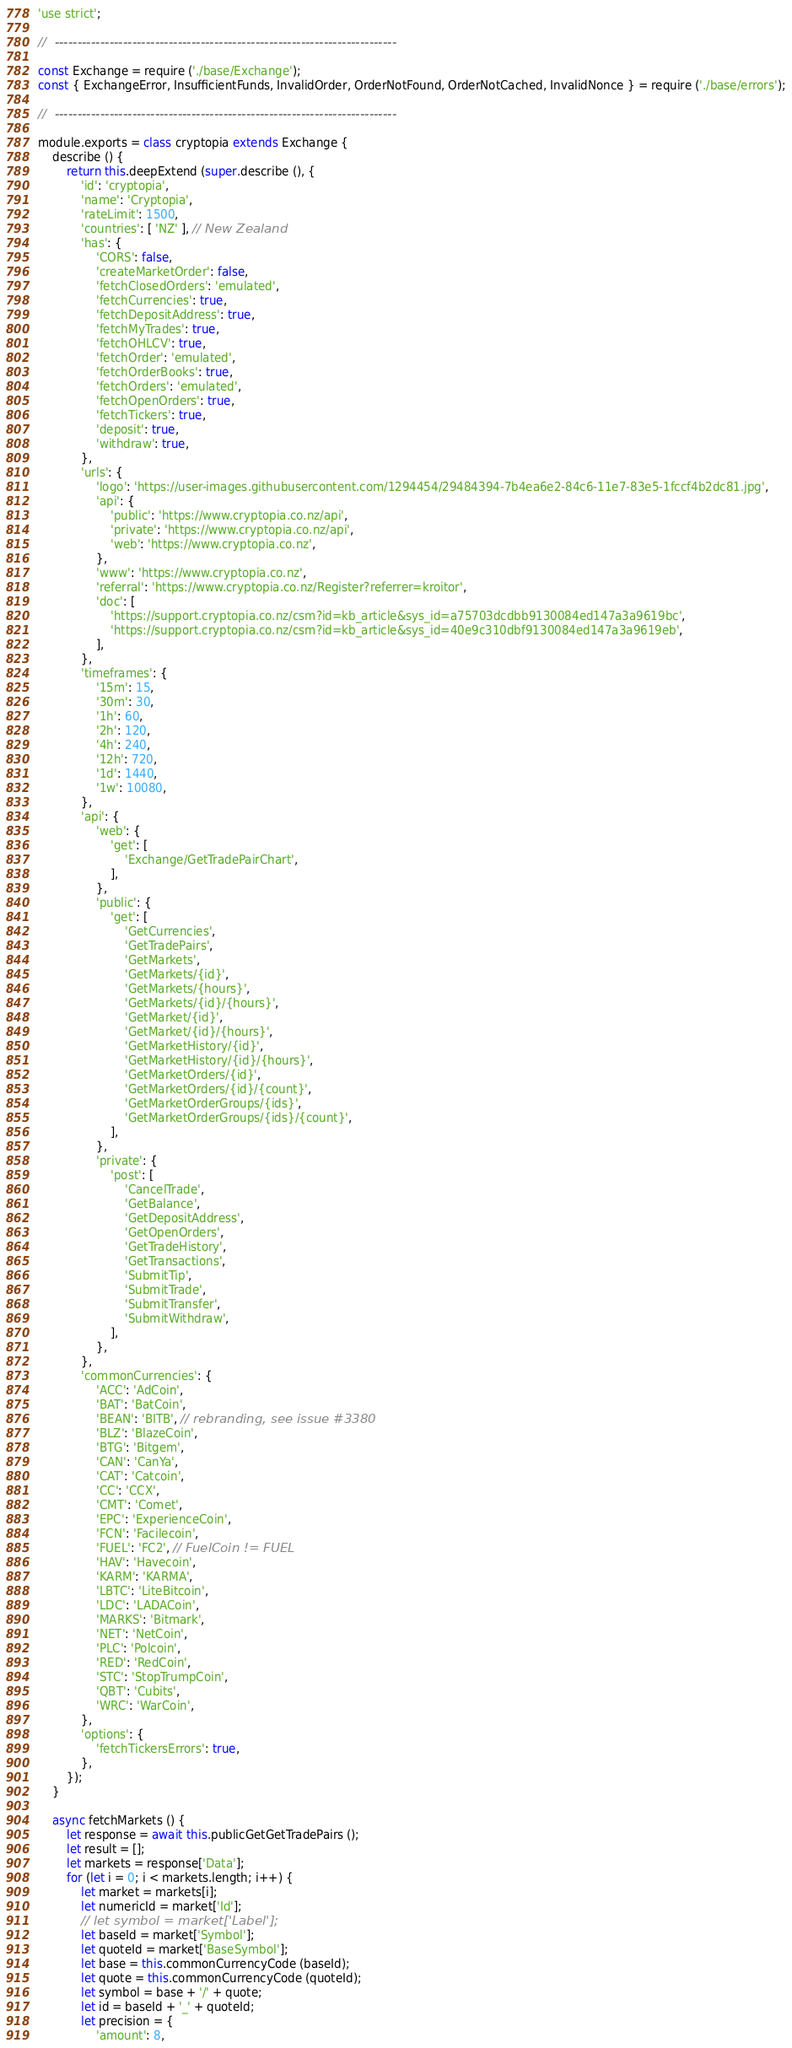<code> <loc_0><loc_0><loc_500><loc_500><_JavaScript_>'use strict';

//  ---------------------------------------------------------------------------

const Exchange = require ('./base/Exchange');
const { ExchangeError, InsufficientFunds, InvalidOrder, OrderNotFound, OrderNotCached, InvalidNonce } = require ('./base/errors');

//  ---------------------------------------------------------------------------

module.exports = class cryptopia extends Exchange {
    describe () {
        return this.deepExtend (super.describe (), {
            'id': 'cryptopia',
            'name': 'Cryptopia',
            'rateLimit': 1500,
            'countries': [ 'NZ' ], // New Zealand
            'has': {
                'CORS': false,
                'createMarketOrder': false,
                'fetchClosedOrders': 'emulated',
                'fetchCurrencies': true,
                'fetchDepositAddress': true,
                'fetchMyTrades': true,
                'fetchOHLCV': true,
                'fetchOrder': 'emulated',
                'fetchOrderBooks': true,
                'fetchOrders': 'emulated',
                'fetchOpenOrders': true,
                'fetchTickers': true,
                'deposit': true,
                'withdraw': true,
            },
            'urls': {
                'logo': 'https://user-images.githubusercontent.com/1294454/29484394-7b4ea6e2-84c6-11e7-83e5-1fccf4b2dc81.jpg',
                'api': {
                    'public': 'https://www.cryptopia.co.nz/api',
                    'private': 'https://www.cryptopia.co.nz/api',
                    'web': 'https://www.cryptopia.co.nz',
                },
                'www': 'https://www.cryptopia.co.nz',
                'referral': 'https://www.cryptopia.co.nz/Register?referrer=kroitor',
                'doc': [
                    'https://support.cryptopia.co.nz/csm?id=kb_article&sys_id=a75703dcdbb9130084ed147a3a9619bc',
                    'https://support.cryptopia.co.nz/csm?id=kb_article&sys_id=40e9c310dbf9130084ed147a3a9619eb',
                ],
            },
            'timeframes': {
                '15m': 15,
                '30m': 30,
                '1h': 60,
                '2h': 120,
                '4h': 240,
                '12h': 720,
                '1d': 1440,
                '1w': 10080,
            },
            'api': {
                'web': {
                    'get': [
                        'Exchange/GetTradePairChart',
                    ],
                },
                'public': {
                    'get': [
                        'GetCurrencies',
                        'GetTradePairs',
                        'GetMarkets',
                        'GetMarkets/{id}',
                        'GetMarkets/{hours}',
                        'GetMarkets/{id}/{hours}',
                        'GetMarket/{id}',
                        'GetMarket/{id}/{hours}',
                        'GetMarketHistory/{id}',
                        'GetMarketHistory/{id}/{hours}',
                        'GetMarketOrders/{id}',
                        'GetMarketOrders/{id}/{count}',
                        'GetMarketOrderGroups/{ids}',
                        'GetMarketOrderGroups/{ids}/{count}',
                    ],
                },
                'private': {
                    'post': [
                        'CancelTrade',
                        'GetBalance',
                        'GetDepositAddress',
                        'GetOpenOrders',
                        'GetTradeHistory',
                        'GetTransactions',
                        'SubmitTip',
                        'SubmitTrade',
                        'SubmitTransfer',
                        'SubmitWithdraw',
                    ],
                },
            },
            'commonCurrencies': {
                'ACC': 'AdCoin',
                'BAT': 'BatCoin',
                'BEAN': 'BITB', // rebranding, see issue #3380
                'BLZ': 'BlazeCoin',
                'BTG': 'Bitgem',
                'CAN': 'CanYa',
                'CAT': 'Catcoin',
                'CC': 'CCX',
                'CMT': 'Comet',
                'EPC': 'ExperienceCoin',
                'FCN': 'Facilecoin',
                'FUEL': 'FC2', // FuelCoin != FUEL
                'HAV': 'Havecoin',
                'KARM': 'KARMA',
                'LBTC': 'LiteBitcoin',
                'LDC': 'LADACoin',
                'MARKS': 'Bitmark',
                'NET': 'NetCoin',
                'PLC': 'Polcoin',
                'RED': 'RedCoin',
                'STC': 'StopTrumpCoin',
                'QBT': 'Cubits',
                'WRC': 'WarCoin',
            },
            'options': {
                'fetchTickersErrors': true,
            },
        });
    }

    async fetchMarkets () {
        let response = await this.publicGetGetTradePairs ();
        let result = [];
        let markets = response['Data'];
        for (let i = 0; i < markets.length; i++) {
            let market = markets[i];
            let numericId = market['Id'];
            // let symbol = market['Label'];
            let baseId = market['Symbol'];
            let quoteId = market['BaseSymbol'];
            let base = this.commonCurrencyCode (baseId);
            let quote = this.commonCurrencyCode (quoteId);
            let symbol = base + '/' + quote;
            let id = baseId + '_' + quoteId;
            let precision = {
                'amount': 8,</code> 